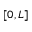<formula> <loc_0><loc_0><loc_500><loc_500>[ 0 , L ]</formula> 